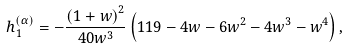<formula> <loc_0><loc_0><loc_500><loc_500>h _ { 1 } ^ { \left ( \alpha \right ) } = - \frac { \left ( 1 + w \right ) ^ { 2 } } { 4 0 w ^ { 3 } } \left ( 1 1 9 - 4 w - 6 w ^ { 2 } - 4 w ^ { 3 } - w ^ { 4 } \right ) ,</formula> 